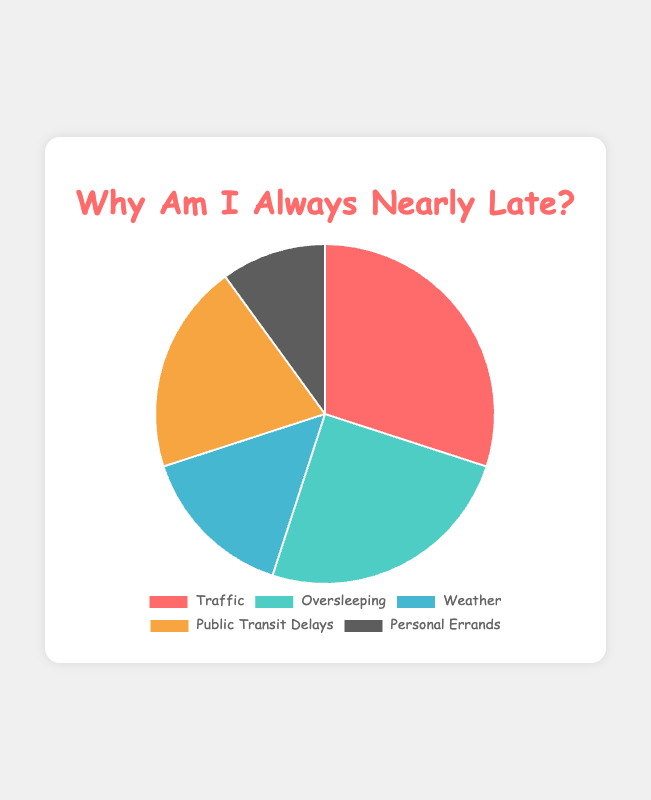What are the top two reasons for being nearly late to work? The top two reasons are the ones with the largest percentages. From the pie chart, the two largest percentages are Traffic (30%) and Oversleeping (25%).
Answer: Traffic and Oversleeping Which reason has the least percentage for being nearly late? The reason with the smallest percentage is the one with the lowest value. From the pie chart, Personal Errands has the smallest percentage with 10%.
Answer: Personal Errands What is the combined percentage of Traffic and Public Transit Delays? To find the combined percentage, sum the percentages of Traffic (30%) and Public Transit Delays (20%). This results in 30% + 20% = 50%.
Answer: 50% Is the percentage of Oversleeping greater than the percentage of Weather? Compare the percentages of Oversleeping (25%) and Weather (15%). Since 25% is greater than 15%, Oversleeping has a higher percentage than Weather.
Answer: Yes How much higher is the percentage of Traffic compared to Personal Errands? To find the difference, subtract the percentage of Personal Errands (10%) from Traffic (30%). This gives 30% - 10% = 20%.
Answer: 20% Rank the reasons from most common to least common for being nearly late. Arrange the reasons in descending order based on their percentages: Traffic (30%), Oversleeping (25%), Public Transit Delays (20%), Weather (15%), Personal Errands (10%).
Answer: Traffic, Oversleeping, Public Transit Delays, Weather, Personal Errands What is the median percentage value of the reasons? List the percentages in ascending order: 10%, 15%, 20%, 25%, 30%. The middle value or the third value in this list is the median, which is 20%.
Answer: 20% By how much does the percentage of Weather differ from the sum of Oversleeping and Personal Errands? First, calculate the sum of Oversleeping (25%) and Personal Errands (10%), which equals 35%. Then subtract the percentage of Weather (15%) from this sum: 35% - 15% = 20%.
Answer: 20% If you combine the percentages of Weather and Personal Errands, do they exceed the percentage of Traffic? Sum the percentages of Weather (15%) and Personal Errands (10%) to get 25%. Compare this with the percentage for Traffic (30%). Since 25% is less than 30%, they do not exceed Traffic.
Answer: No Out of the given reasons, which one uses a red color in the visualization? According to the description, Traffic uses the color red.
Answer: Traffic 